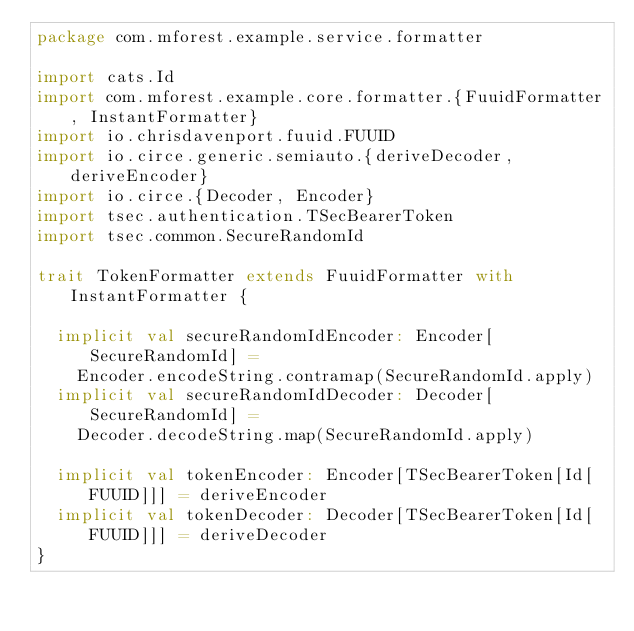Convert code to text. <code><loc_0><loc_0><loc_500><loc_500><_Scala_>package com.mforest.example.service.formatter

import cats.Id
import com.mforest.example.core.formatter.{FuuidFormatter, InstantFormatter}
import io.chrisdavenport.fuuid.FUUID
import io.circe.generic.semiauto.{deriveDecoder, deriveEncoder}
import io.circe.{Decoder, Encoder}
import tsec.authentication.TSecBearerToken
import tsec.common.SecureRandomId

trait TokenFormatter extends FuuidFormatter with InstantFormatter {

  implicit val secureRandomIdEncoder: Encoder[SecureRandomId] =
    Encoder.encodeString.contramap(SecureRandomId.apply)
  implicit val secureRandomIdDecoder: Decoder[SecureRandomId] =
    Decoder.decodeString.map(SecureRandomId.apply)

  implicit val tokenEncoder: Encoder[TSecBearerToken[Id[FUUID]]] = deriveEncoder
  implicit val tokenDecoder: Decoder[TSecBearerToken[Id[FUUID]]] = deriveDecoder
}
</code> 